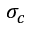<formula> <loc_0><loc_0><loc_500><loc_500>\sigma _ { c }</formula> 